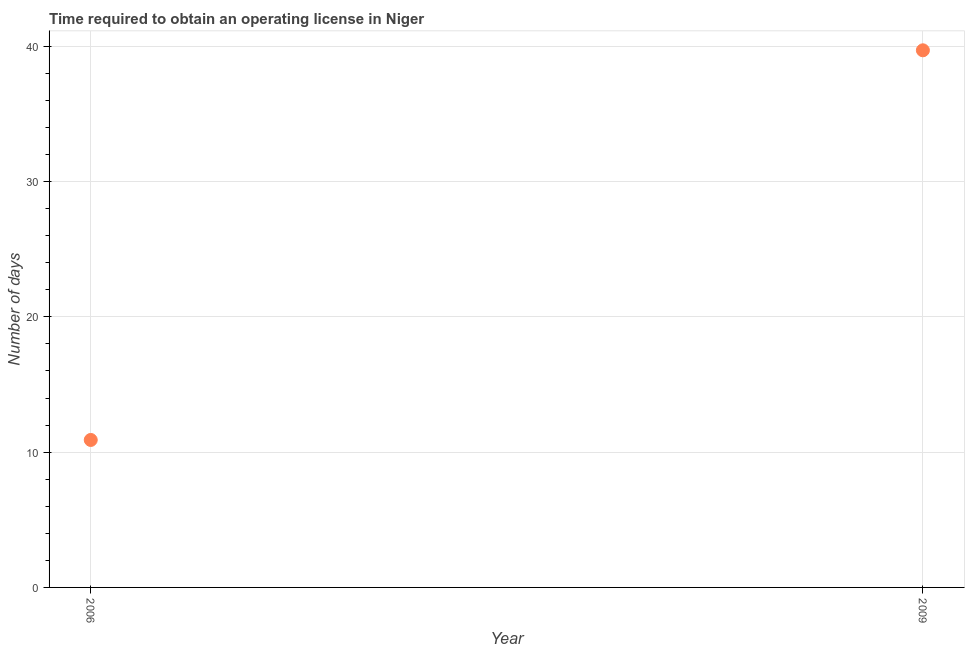What is the number of days to obtain operating license in 2009?
Provide a short and direct response. 39.7. Across all years, what is the maximum number of days to obtain operating license?
Provide a short and direct response. 39.7. Across all years, what is the minimum number of days to obtain operating license?
Offer a very short reply. 10.9. In which year was the number of days to obtain operating license minimum?
Offer a terse response. 2006. What is the sum of the number of days to obtain operating license?
Offer a terse response. 50.6. What is the difference between the number of days to obtain operating license in 2006 and 2009?
Ensure brevity in your answer.  -28.8. What is the average number of days to obtain operating license per year?
Offer a terse response. 25.3. What is the median number of days to obtain operating license?
Your answer should be very brief. 25.3. Do a majority of the years between 2009 and 2006 (inclusive) have number of days to obtain operating license greater than 22 days?
Provide a short and direct response. No. What is the ratio of the number of days to obtain operating license in 2006 to that in 2009?
Give a very brief answer. 0.27. Is the number of days to obtain operating license in 2006 less than that in 2009?
Ensure brevity in your answer.  Yes. How many years are there in the graph?
Provide a short and direct response. 2. Does the graph contain any zero values?
Make the answer very short. No. What is the title of the graph?
Your answer should be compact. Time required to obtain an operating license in Niger. What is the label or title of the Y-axis?
Give a very brief answer. Number of days. What is the Number of days in 2009?
Keep it short and to the point. 39.7. What is the difference between the Number of days in 2006 and 2009?
Provide a succinct answer. -28.8. What is the ratio of the Number of days in 2006 to that in 2009?
Your answer should be compact. 0.28. 